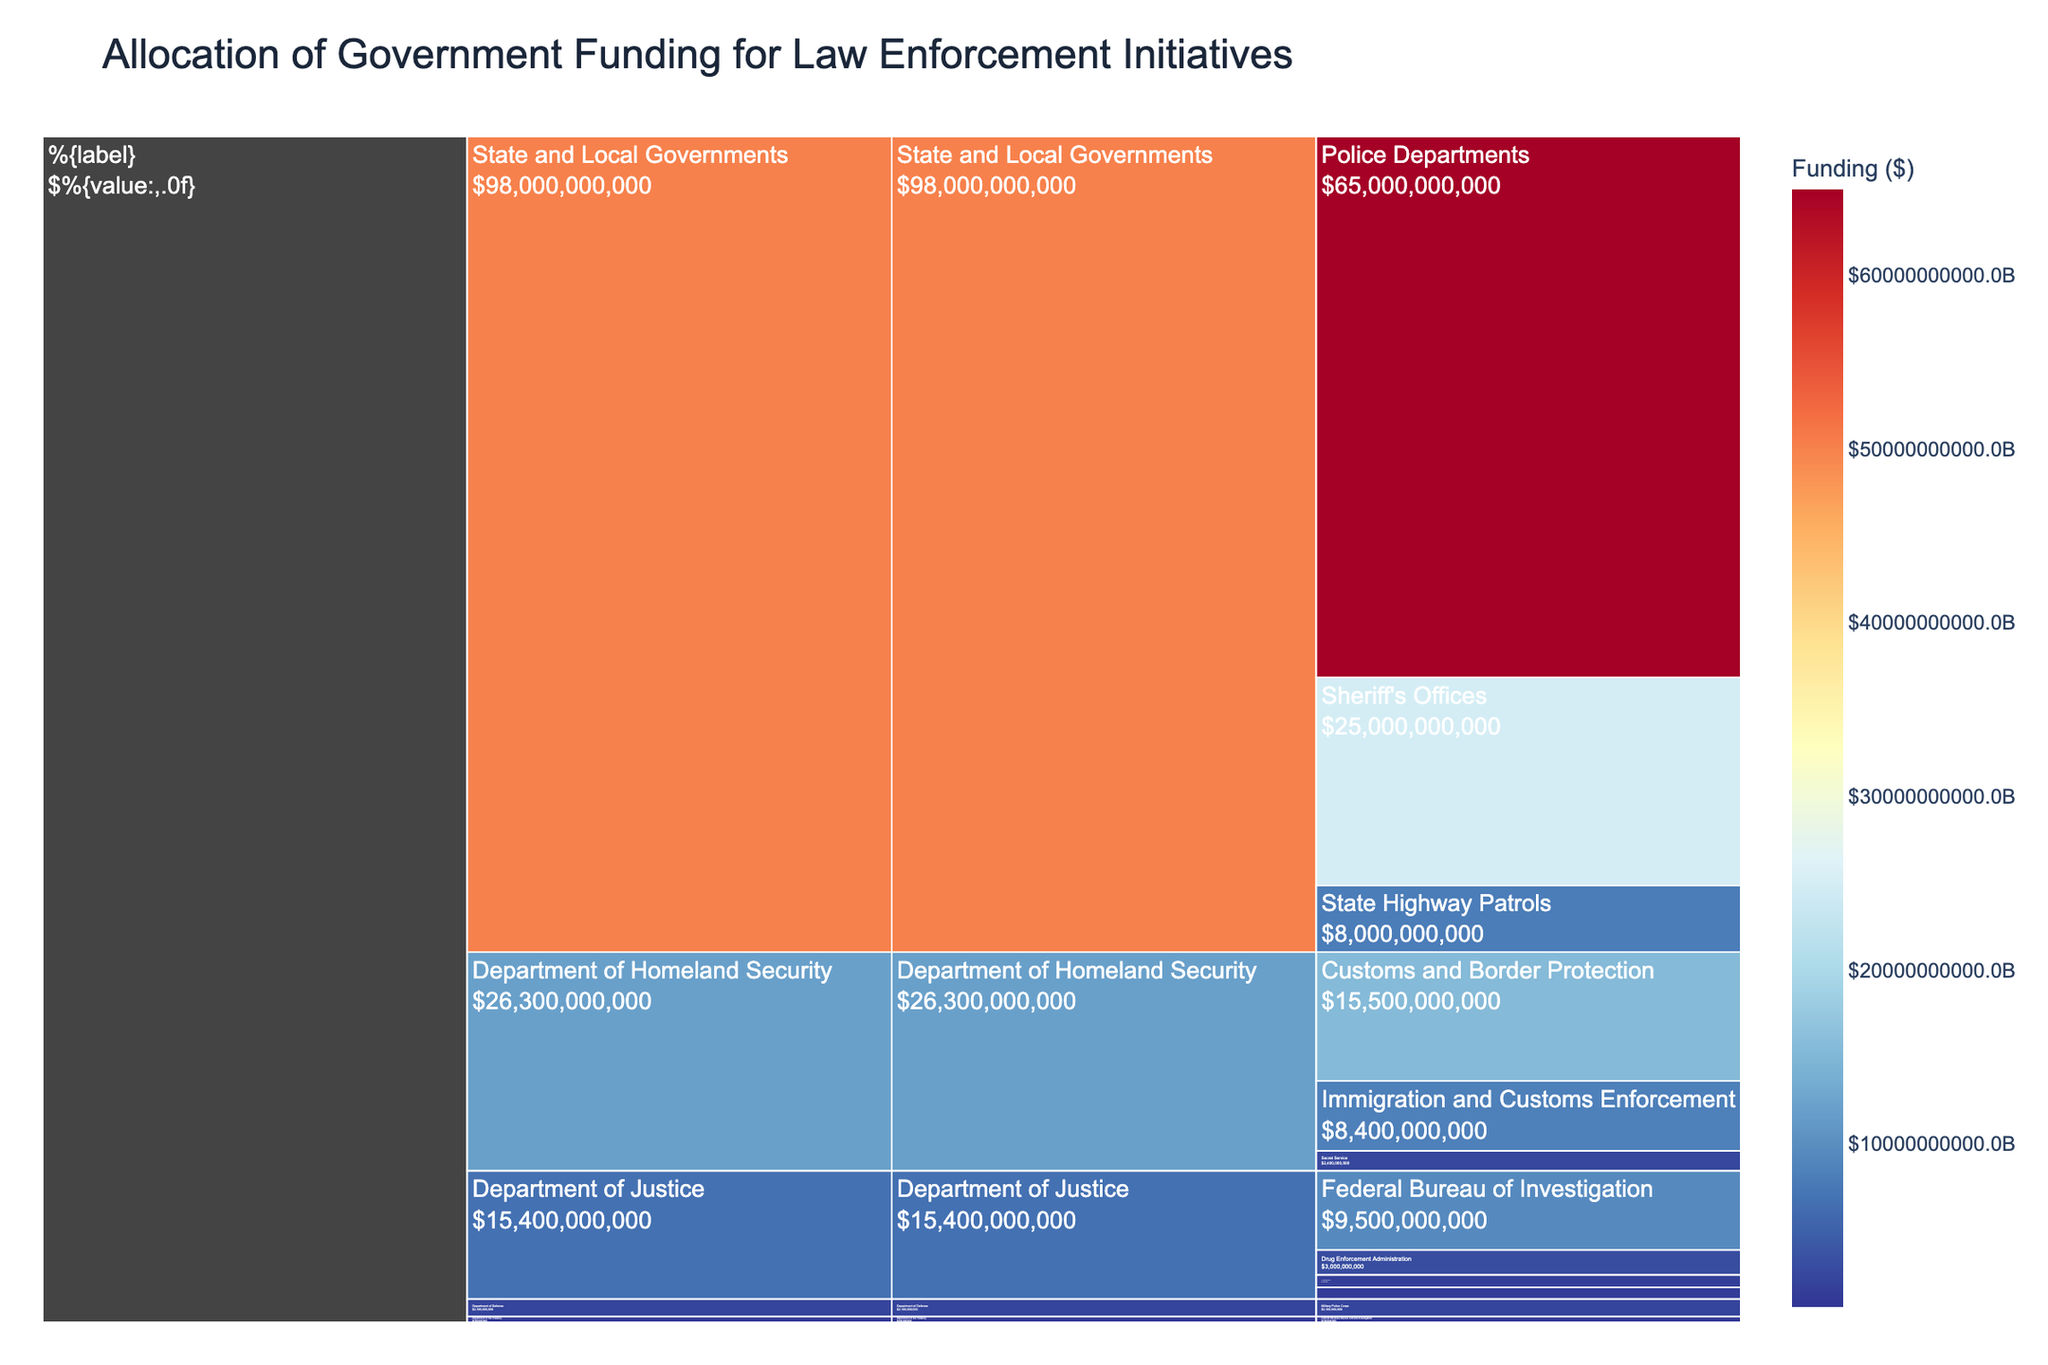What is the title of the Icicle Chart? The title of the chart is located at the top and is usually larger and more prominent than other text. Look at the top-middle part of the chart to find it.
Answer: Allocation of Government Funding for Law Enforcement Initiatives Which Department has the highest total funding? Summing up the values by Department and comparing them, the one with the highest total funding will be the answer. The largest block in the Icicle Chart will represent the department with the highest funding.
Answer: State and Local Governments How much funding is allocated to the Customs and Border Protection program? Locate the Customs and Border Protection program on the chart. The value associated with it is directly provided.
Answer: $15,500,000,000 How does the funding for the Federal Bureau of Investigation compare to the U.S. Marshals Service? Locate both programs on the chart. Compare their values, the FBI value diverts significantly more funding.
Answer: The Federal Bureau of Investigation has more funding than the U.S. Marshals Service What is the combined funding for the Internal Revenue Service Criminal Investigation and Secret Service programs? Sum the funding amounts for Internal Revenue Service Criminal Investigation ($700,000,000) and Secret Service ($2,400,000,000). The combined funding will be the total.
Answer: $3,100,000,000 What are the programs under the Department of Homeland Security? The Department of Homeland Security in the chart branches into several programs. Check the branches directly under this department.
Answer: Customs and Border Protection, Immigration and Customs Enforcement, Secret Service Which department receives less funding, the Department of the Treasury or the Department of Defense? Compare the allocated funding for both departments.
Answer: Department of the Treasury How are State and Local Government funds distributed among Police Departments, Sheriff's Offices, and State Highway Patrols? Check the branches under State and Local Governments and list the funding for each program.
Answer: Police Departments: $65,000,000,000, Sheriff's Offices: $25,000,000,000, State Highway Patrols: $8,000,000,000 Is the funding for Drug Enforcement Administration closer to that of Bureau of Alcohol Tobacco Firearms and Explosives or U.S. Marshals Service? Compare the funding values of the Drug Enforcement Administration, Bureau of Alcohol Tobacco Firearms and Explosives, and U.S. Marshals Service.
Answer: U.S. Marshals Service What percentage of the total funding does the Secret Service receive? Sum all funding values to get the total funding. Calculate the percentage of the total funding that the Secret Service's funding represents using the formula (Secret Service / Total Funding) * 100.
Answer: ~1.92% 